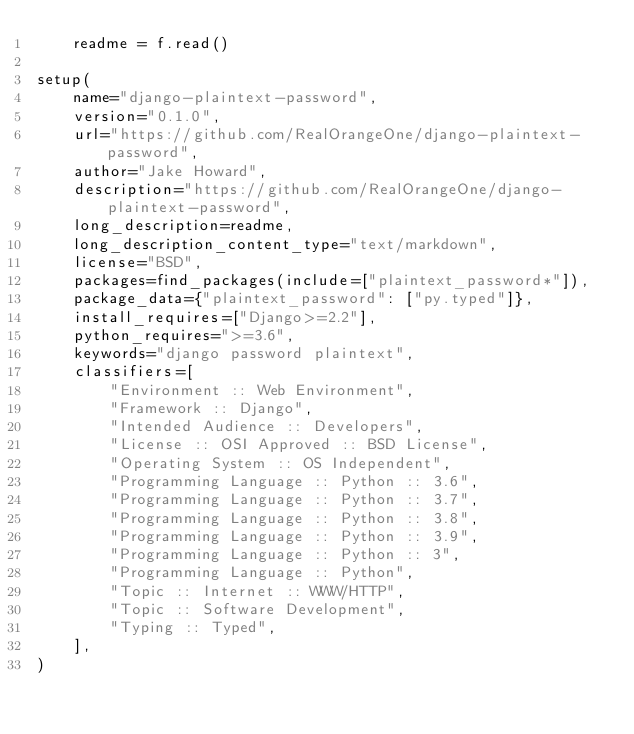<code> <loc_0><loc_0><loc_500><loc_500><_Python_>    readme = f.read()

setup(
    name="django-plaintext-password",
    version="0.1.0",
    url="https://github.com/RealOrangeOne/django-plaintext-password",
    author="Jake Howard",
    description="https://github.com/RealOrangeOne/django-plaintext-password",
    long_description=readme,
    long_description_content_type="text/markdown",
    license="BSD",
    packages=find_packages(include=["plaintext_password*"]),
    package_data={"plaintext_password": ["py.typed"]},
    install_requires=["Django>=2.2"],
    python_requires=">=3.6",
    keywords="django password plaintext",
    classifiers=[
        "Environment :: Web Environment",
        "Framework :: Django",
        "Intended Audience :: Developers",
        "License :: OSI Approved :: BSD License",
        "Operating System :: OS Independent",
        "Programming Language :: Python :: 3.6",
        "Programming Language :: Python :: 3.7",
        "Programming Language :: Python :: 3.8",
        "Programming Language :: Python :: 3.9",
        "Programming Language :: Python :: 3",
        "Programming Language :: Python",
        "Topic :: Internet :: WWW/HTTP",
        "Topic :: Software Development",
        "Typing :: Typed",
    ],
)
</code> 